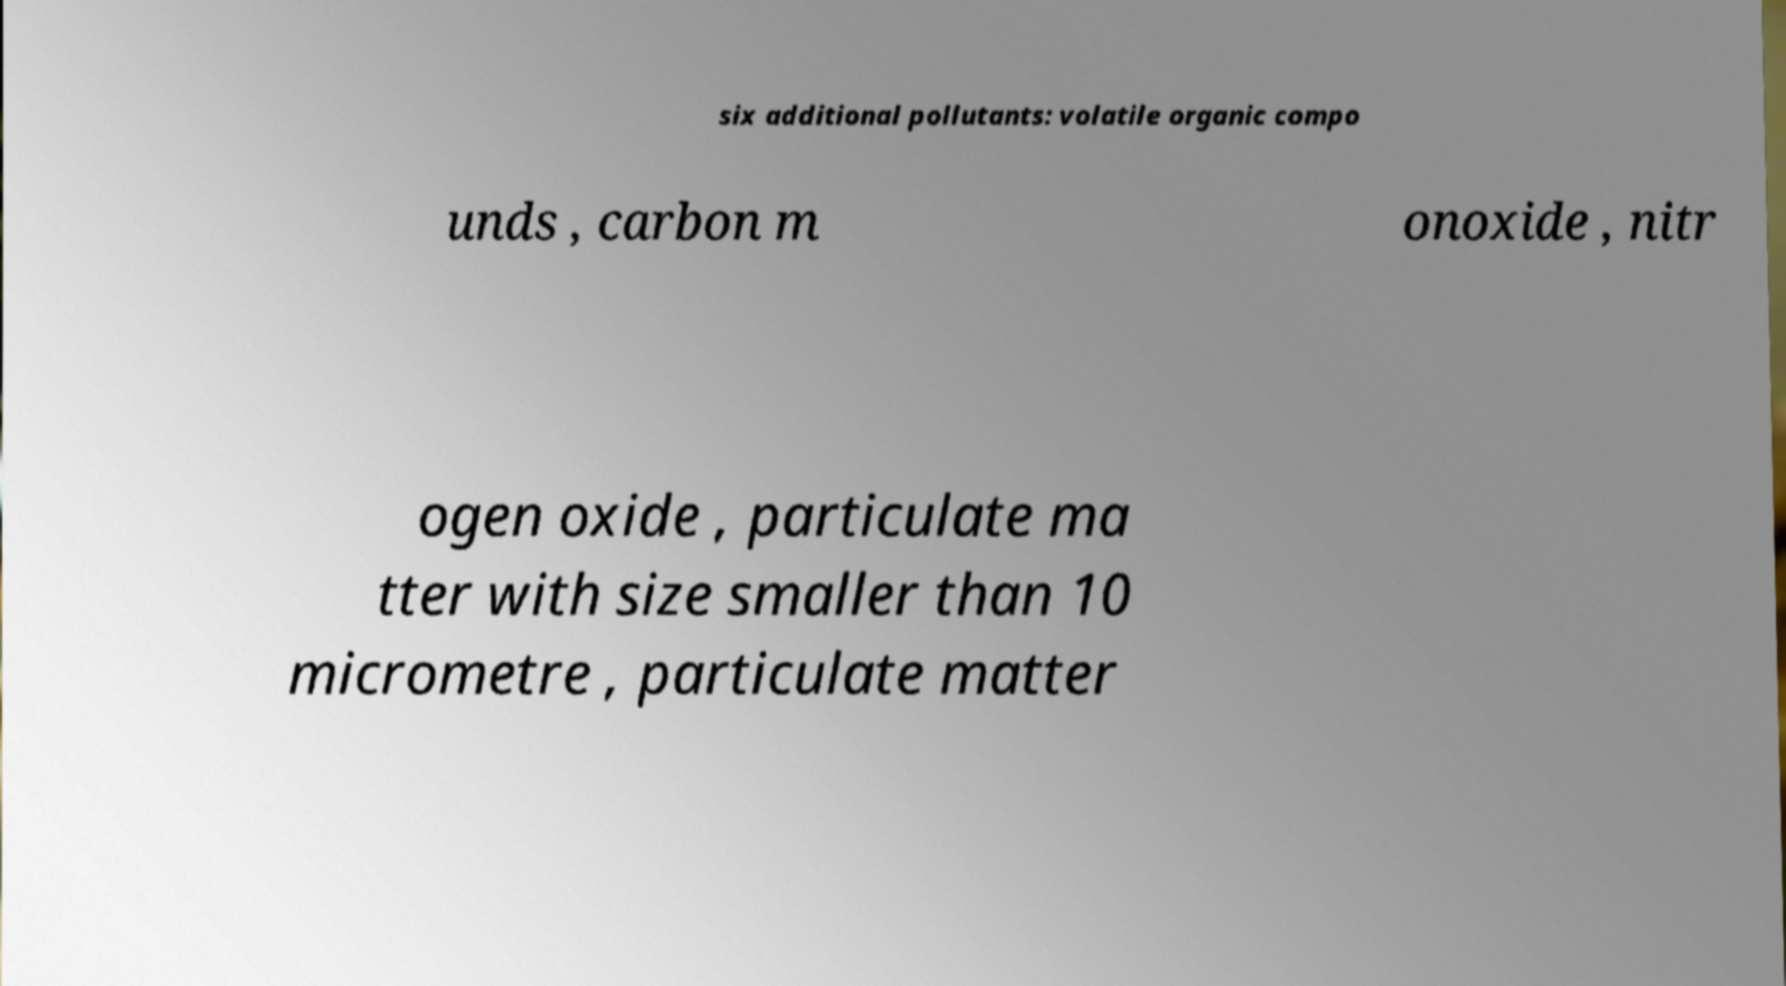Can you accurately transcribe the text from the provided image for me? six additional pollutants: volatile organic compo unds , carbon m onoxide , nitr ogen oxide , particulate ma tter with size smaller than 10 micrometre , particulate matter 